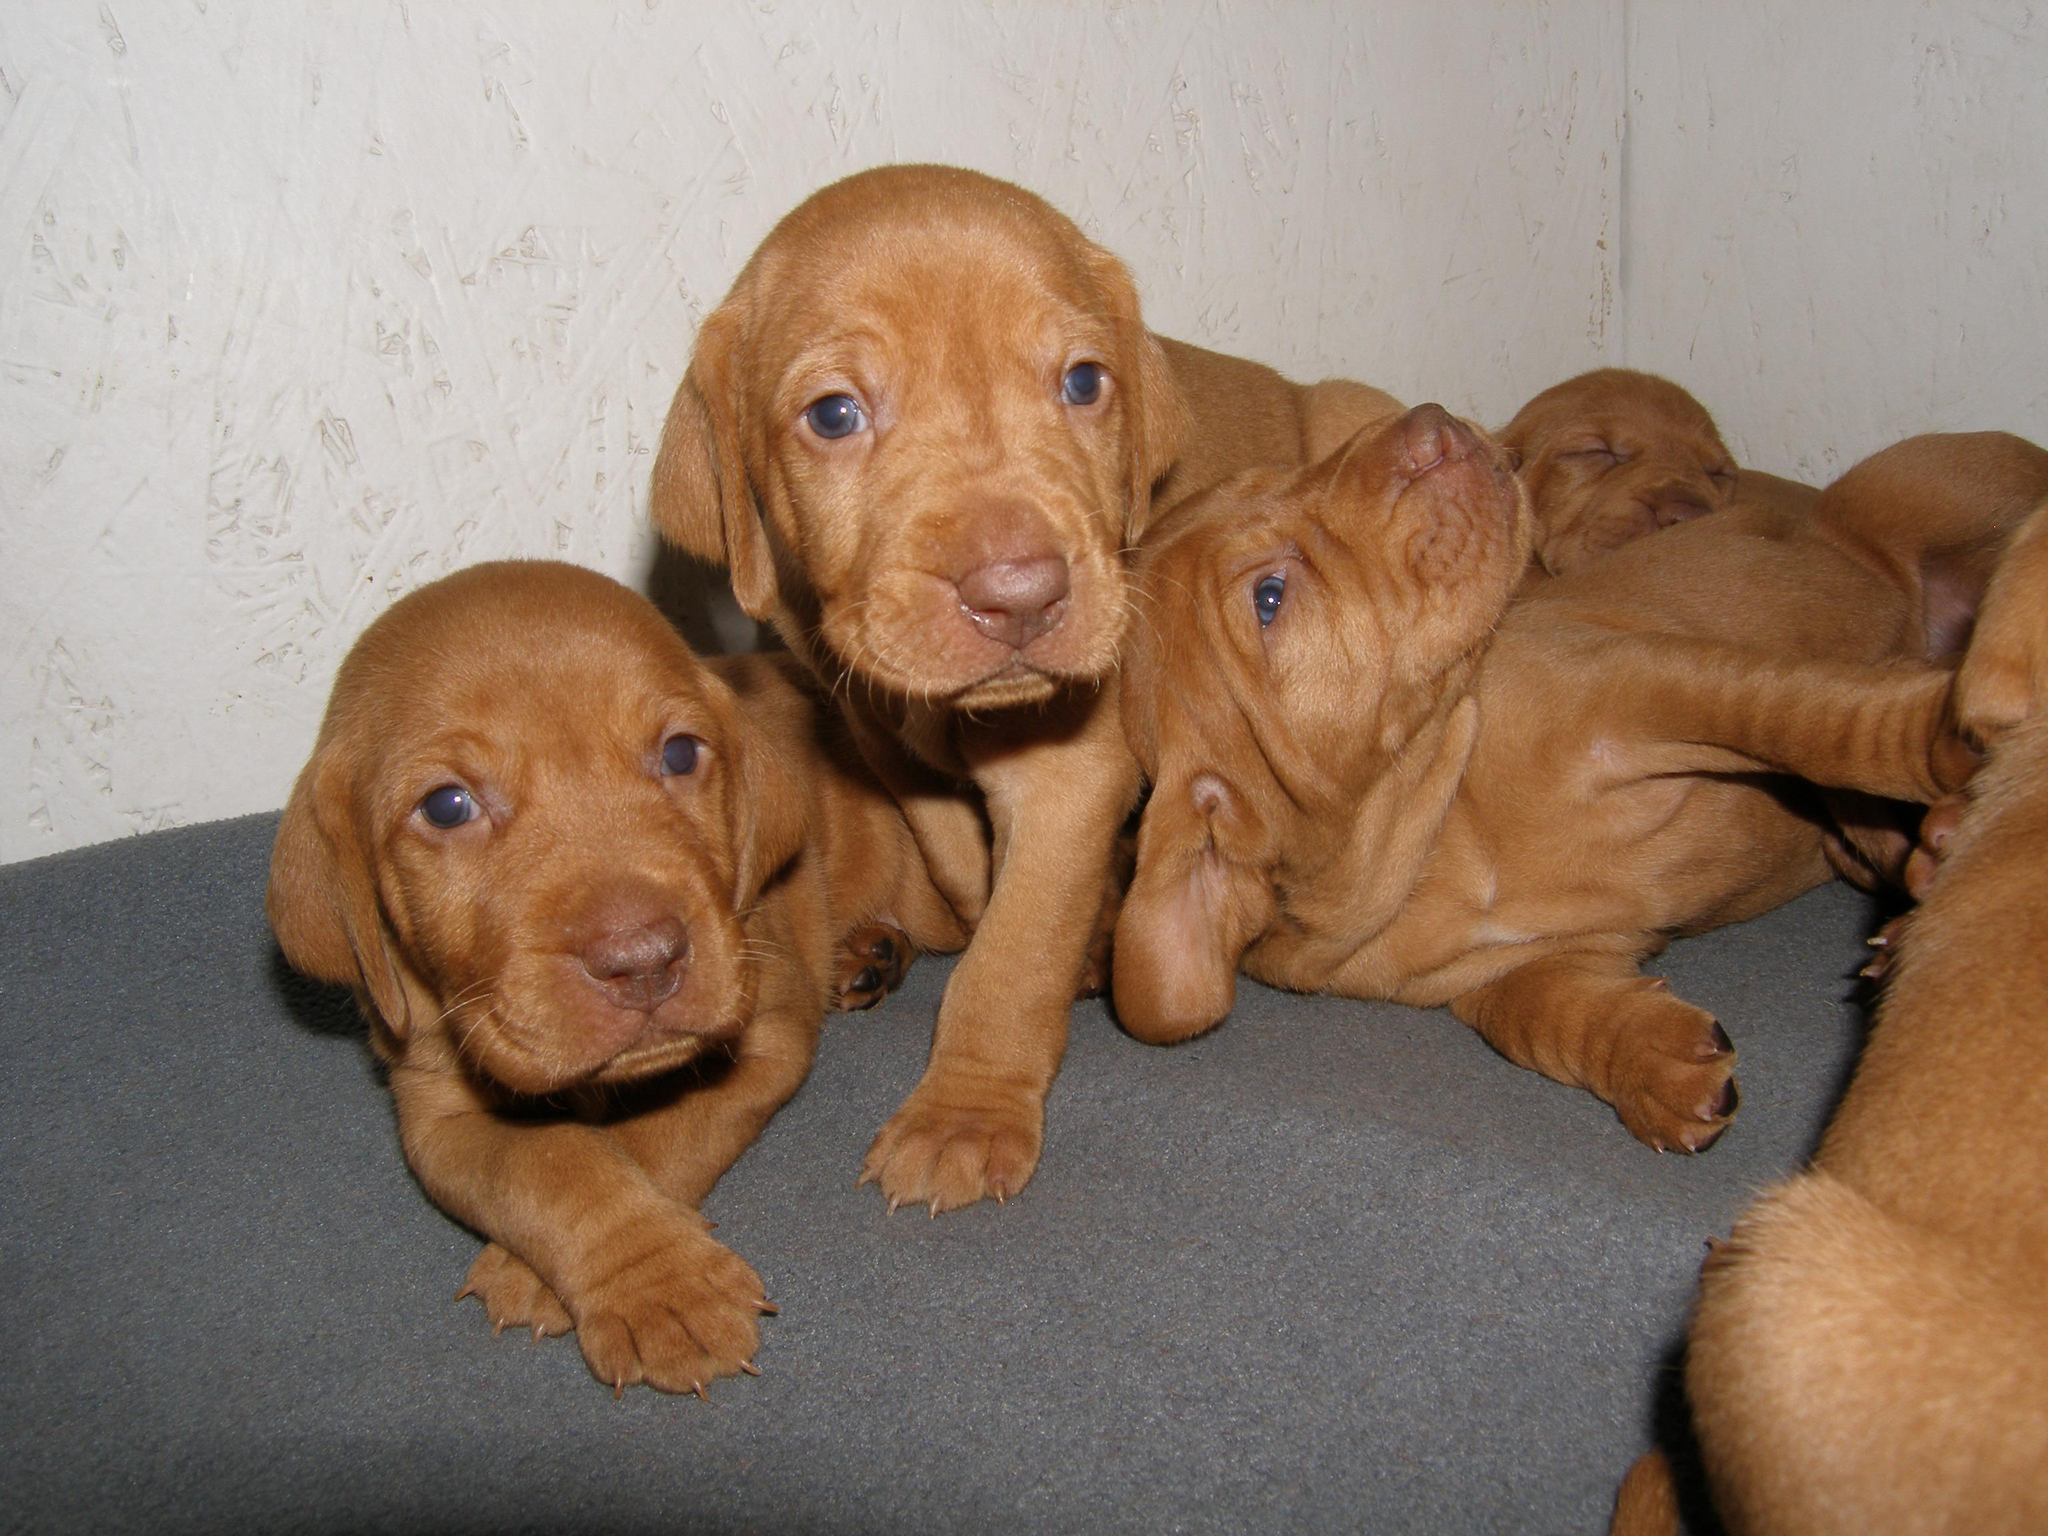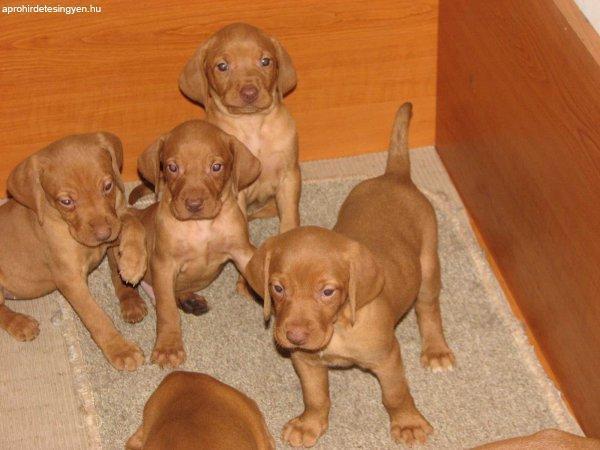The first image is the image on the left, the second image is the image on the right. For the images displayed, is the sentence "An image shows exactly one dog reclining on a soft piece of furniture, with its rear to the right and its head to the left." factually correct? Answer yes or no. No. The first image is the image on the left, the second image is the image on the right. Considering the images on both sides, is "There are no more than two dogs." valid? Answer yes or no. No. 